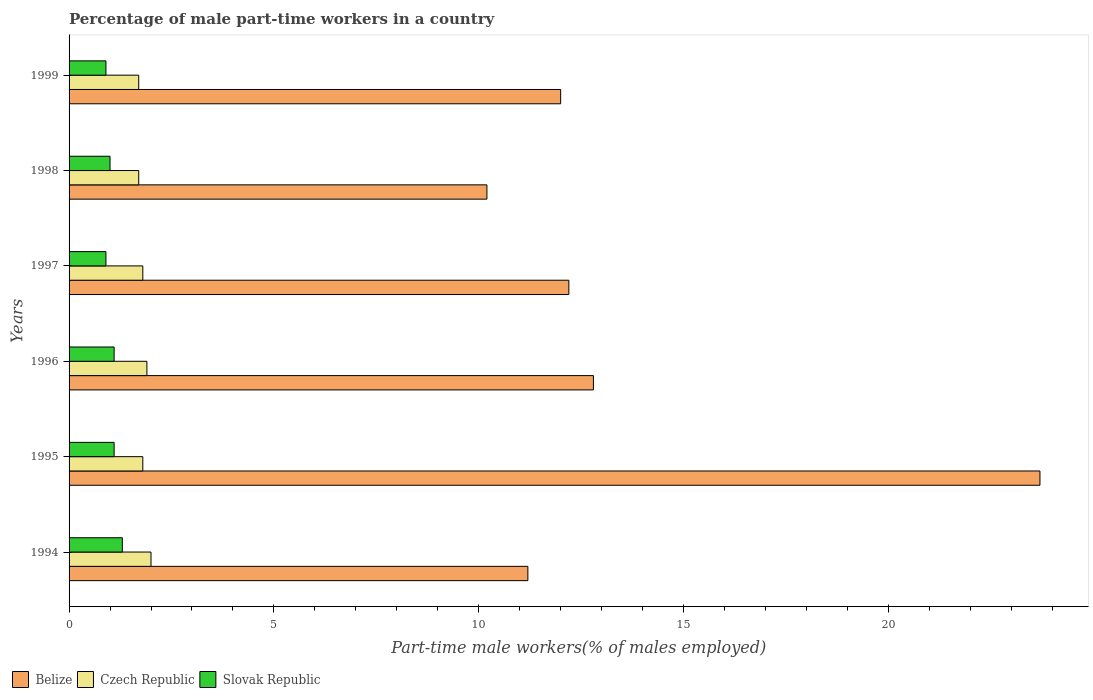How many bars are there on the 4th tick from the top?
Your answer should be very brief. 3. How many bars are there on the 1st tick from the bottom?
Offer a very short reply. 3. In how many cases, is the number of bars for a given year not equal to the number of legend labels?
Offer a very short reply. 0. What is the percentage of male part-time workers in Czech Republic in 1994?
Provide a short and direct response. 2. Across all years, what is the maximum percentage of male part-time workers in Slovak Republic?
Offer a very short reply. 1.3. Across all years, what is the minimum percentage of male part-time workers in Slovak Republic?
Offer a very short reply. 0.9. In which year was the percentage of male part-time workers in Belize minimum?
Provide a succinct answer. 1998. What is the total percentage of male part-time workers in Czech Republic in the graph?
Offer a very short reply. 10.9. What is the difference between the percentage of male part-time workers in Slovak Republic in 1998 and that in 1999?
Your answer should be very brief. 0.1. What is the difference between the percentage of male part-time workers in Belize in 1995 and the percentage of male part-time workers in Czech Republic in 1997?
Provide a short and direct response. 21.9. What is the average percentage of male part-time workers in Slovak Republic per year?
Provide a short and direct response. 1.05. In the year 1999, what is the difference between the percentage of male part-time workers in Belize and percentage of male part-time workers in Czech Republic?
Keep it short and to the point. 10.3. In how many years, is the percentage of male part-time workers in Belize greater than 5 %?
Provide a succinct answer. 6. Is the difference between the percentage of male part-time workers in Belize in 1994 and 1996 greater than the difference between the percentage of male part-time workers in Czech Republic in 1994 and 1996?
Your response must be concise. No. What is the difference between the highest and the second highest percentage of male part-time workers in Slovak Republic?
Offer a terse response. 0.2. What is the difference between the highest and the lowest percentage of male part-time workers in Belize?
Make the answer very short. 13.5. In how many years, is the percentage of male part-time workers in Slovak Republic greater than the average percentage of male part-time workers in Slovak Republic taken over all years?
Offer a very short reply. 3. What does the 3rd bar from the top in 1996 represents?
Offer a very short reply. Belize. What does the 1st bar from the bottom in 1997 represents?
Your answer should be compact. Belize. Is it the case that in every year, the sum of the percentage of male part-time workers in Belize and percentage of male part-time workers in Slovak Republic is greater than the percentage of male part-time workers in Czech Republic?
Make the answer very short. Yes. How many years are there in the graph?
Provide a short and direct response. 6. Are the values on the major ticks of X-axis written in scientific E-notation?
Give a very brief answer. No. Does the graph contain grids?
Offer a terse response. No. How many legend labels are there?
Your response must be concise. 3. How are the legend labels stacked?
Ensure brevity in your answer.  Horizontal. What is the title of the graph?
Your response must be concise. Percentage of male part-time workers in a country. Does "Cote d'Ivoire" appear as one of the legend labels in the graph?
Make the answer very short. No. What is the label or title of the X-axis?
Your answer should be compact. Part-time male workers(% of males employed). What is the Part-time male workers(% of males employed) in Belize in 1994?
Keep it short and to the point. 11.2. What is the Part-time male workers(% of males employed) in Slovak Republic in 1994?
Provide a succinct answer. 1.3. What is the Part-time male workers(% of males employed) in Belize in 1995?
Ensure brevity in your answer.  23.7. What is the Part-time male workers(% of males employed) of Czech Republic in 1995?
Provide a short and direct response. 1.8. What is the Part-time male workers(% of males employed) in Slovak Republic in 1995?
Your answer should be compact. 1.1. What is the Part-time male workers(% of males employed) in Belize in 1996?
Offer a terse response. 12.8. What is the Part-time male workers(% of males employed) of Czech Republic in 1996?
Give a very brief answer. 1.9. What is the Part-time male workers(% of males employed) of Slovak Republic in 1996?
Offer a very short reply. 1.1. What is the Part-time male workers(% of males employed) in Belize in 1997?
Offer a very short reply. 12.2. What is the Part-time male workers(% of males employed) of Czech Republic in 1997?
Your response must be concise. 1.8. What is the Part-time male workers(% of males employed) of Slovak Republic in 1997?
Your response must be concise. 0.9. What is the Part-time male workers(% of males employed) of Belize in 1998?
Keep it short and to the point. 10.2. What is the Part-time male workers(% of males employed) of Czech Republic in 1998?
Make the answer very short. 1.7. What is the Part-time male workers(% of males employed) of Czech Republic in 1999?
Offer a terse response. 1.7. What is the Part-time male workers(% of males employed) in Slovak Republic in 1999?
Provide a short and direct response. 0.9. Across all years, what is the maximum Part-time male workers(% of males employed) in Belize?
Your answer should be very brief. 23.7. Across all years, what is the maximum Part-time male workers(% of males employed) of Czech Republic?
Provide a succinct answer. 2. Across all years, what is the maximum Part-time male workers(% of males employed) of Slovak Republic?
Make the answer very short. 1.3. Across all years, what is the minimum Part-time male workers(% of males employed) in Belize?
Ensure brevity in your answer.  10.2. Across all years, what is the minimum Part-time male workers(% of males employed) of Czech Republic?
Your response must be concise. 1.7. Across all years, what is the minimum Part-time male workers(% of males employed) in Slovak Republic?
Offer a very short reply. 0.9. What is the total Part-time male workers(% of males employed) of Belize in the graph?
Ensure brevity in your answer.  82.1. What is the difference between the Part-time male workers(% of males employed) in Belize in 1994 and that in 1995?
Offer a very short reply. -12.5. What is the difference between the Part-time male workers(% of males employed) in Czech Republic in 1994 and that in 1995?
Make the answer very short. 0.2. What is the difference between the Part-time male workers(% of males employed) of Slovak Republic in 1994 and that in 1995?
Provide a succinct answer. 0.2. What is the difference between the Part-time male workers(% of males employed) in Slovak Republic in 1994 and that in 1996?
Make the answer very short. 0.2. What is the difference between the Part-time male workers(% of males employed) in Czech Republic in 1994 and that in 1997?
Provide a short and direct response. 0.2. What is the difference between the Part-time male workers(% of males employed) of Slovak Republic in 1994 and that in 1997?
Your response must be concise. 0.4. What is the difference between the Part-time male workers(% of males employed) of Belize in 1994 and that in 1998?
Your answer should be very brief. 1. What is the difference between the Part-time male workers(% of males employed) in Czech Republic in 1994 and that in 1999?
Your response must be concise. 0.3. What is the difference between the Part-time male workers(% of males employed) of Slovak Republic in 1994 and that in 1999?
Ensure brevity in your answer.  0.4. What is the difference between the Part-time male workers(% of males employed) of Czech Republic in 1995 and that in 1996?
Your response must be concise. -0.1. What is the difference between the Part-time male workers(% of males employed) in Czech Republic in 1995 and that in 1997?
Make the answer very short. 0. What is the difference between the Part-time male workers(% of males employed) of Slovak Republic in 1995 and that in 1998?
Your answer should be compact. 0.1. What is the difference between the Part-time male workers(% of males employed) in Belize in 1995 and that in 1999?
Provide a short and direct response. 11.7. What is the difference between the Part-time male workers(% of males employed) of Belize in 1996 and that in 1997?
Your answer should be very brief. 0.6. What is the difference between the Part-time male workers(% of males employed) in Belize in 1996 and that in 1998?
Offer a very short reply. 2.6. What is the difference between the Part-time male workers(% of males employed) of Slovak Republic in 1996 and that in 1999?
Your response must be concise. 0.2. What is the difference between the Part-time male workers(% of males employed) of Belize in 1997 and that in 1998?
Your answer should be very brief. 2. What is the difference between the Part-time male workers(% of males employed) of Slovak Republic in 1997 and that in 1998?
Your answer should be compact. -0.1. What is the difference between the Part-time male workers(% of males employed) of Slovak Republic in 1997 and that in 1999?
Provide a short and direct response. 0. What is the difference between the Part-time male workers(% of males employed) in Belize in 1998 and that in 1999?
Offer a very short reply. -1.8. What is the difference between the Part-time male workers(% of males employed) in Czech Republic in 1998 and that in 1999?
Offer a very short reply. 0. What is the difference between the Part-time male workers(% of males employed) of Belize in 1994 and the Part-time male workers(% of males employed) of Czech Republic in 1995?
Your response must be concise. 9.4. What is the difference between the Part-time male workers(% of males employed) of Belize in 1994 and the Part-time male workers(% of males employed) of Czech Republic in 1996?
Give a very brief answer. 9.3. What is the difference between the Part-time male workers(% of males employed) of Belize in 1994 and the Part-time male workers(% of males employed) of Czech Republic in 1997?
Your response must be concise. 9.4. What is the difference between the Part-time male workers(% of males employed) of Belize in 1994 and the Part-time male workers(% of males employed) of Czech Republic in 1998?
Offer a very short reply. 9.5. What is the difference between the Part-time male workers(% of males employed) in Belize in 1994 and the Part-time male workers(% of males employed) in Slovak Republic in 1998?
Your response must be concise. 10.2. What is the difference between the Part-time male workers(% of males employed) of Belize in 1994 and the Part-time male workers(% of males employed) of Czech Republic in 1999?
Your answer should be very brief. 9.5. What is the difference between the Part-time male workers(% of males employed) in Belize in 1994 and the Part-time male workers(% of males employed) in Slovak Republic in 1999?
Your response must be concise. 10.3. What is the difference between the Part-time male workers(% of males employed) of Belize in 1995 and the Part-time male workers(% of males employed) of Czech Republic in 1996?
Ensure brevity in your answer.  21.8. What is the difference between the Part-time male workers(% of males employed) in Belize in 1995 and the Part-time male workers(% of males employed) in Slovak Republic in 1996?
Give a very brief answer. 22.6. What is the difference between the Part-time male workers(% of males employed) in Czech Republic in 1995 and the Part-time male workers(% of males employed) in Slovak Republic in 1996?
Provide a short and direct response. 0.7. What is the difference between the Part-time male workers(% of males employed) of Belize in 1995 and the Part-time male workers(% of males employed) of Czech Republic in 1997?
Offer a very short reply. 21.9. What is the difference between the Part-time male workers(% of males employed) of Belize in 1995 and the Part-time male workers(% of males employed) of Slovak Republic in 1997?
Keep it short and to the point. 22.8. What is the difference between the Part-time male workers(% of males employed) of Czech Republic in 1995 and the Part-time male workers(% of males employed) of Slovak Republic in 1997?
Offer a very short reply. 0.9. What is the difference between the Part-time male workers(% of males employed) in Belize in 1995 and the Part-time male workers(% of males employed) in Czech Republic in 1998?
Give a very brief answer. 22. What is the difference between the Part-time male workers(% of males employed) in Belize in 1995 and the Part-time male workers(% of males employed) in Slovak Republic in 1998?
Your response must be concise. 22.7. What is the difference between the Part-time male workers(% of males employed) of Czech Republic in 1995 and the Part-time male workers(% of males employed) of Slovak Republic in 1998?
Ensure brevity in your answer.  0.8. What is the difference between the Part-time male workers(% of males employed) of Belize in 1995 and the Part-time male workers(% of males employed) of Slovak Republic in 1999?
Give a very brief answer. 22.8. What is the difference between the Part-time male workers(% of males employed) of Belize in 1996 and the Part-time male workers(% of males employed) of Czech Republic in 1997?
Give a very brief answer. 11. What is the difference between the Part-time male workers(% of males employed) in Belize in 1996 and the Part-time male workers(% of males employed) in Slovak Republic in 1998?
Offer a very short reply. 11.8. What is the difference between the Part-time male workers(% of males employed) of Belize in 1996 and the Part-time male workers(% of males employed) of Czech Republic in 1999?
Your answer should be very brief. 11.1. What is the difference between the Part-time male workers(% of males employed) in Czech Republic in 1996 and the Part-time male workers(% of males employed) in Slovak Republic in 1999?
Your answer should be compact. 1. What is the difference between the Part-time male workers(% of males employed) in Belize in 1997 and the Part-time male workers(% of males employed) in Czech Republic in 1998?
Keep it short and to the point. 10.5. What is the difference between the Part-time male workers(% of males employed) of Czech Republic in 1997 and the Part-time male workers(% of males employed) of Slovak Republic in 1998?
Your answer should be very brief. 0.8. What is the difference between the Part-time male workers(% of males employed) of Belize in 1997 and the Part-time male workers(% of males employed) of Czech Republic in 1999?
Ensure brevity in your answer.  10.5. What is the difference between the Part-time male workers(% of males employed) in Czech Republic in 1997 and the Part-time male workers(% of males employed) in Slovak Republic in 1999?
Your answer should be very brief. 0.9. What is the average Part-time male workers(% of males employed) of Belize per year?
Offer a terse response. 13.68. What is the average Part-time male workers(% of males employed) in Czech Republic per year?
Offer a terse response. 1.82. In the year 1994, what is the difference between the Part-time male workers(% of males employed) in Belize and Part-time male workers(% of males employed) in Slovak Republic?
Make the answer very short. 9.9. In the year 1994, what is the difference between the Part-time male workers(% of males employed) of Czech Republic and Part-time male workers(% of males employed) of Slovak Republic?
Offer a terse response. 0.7. In the year 1995, what is the difference between the Part-time male workers(% of males employed) in Belize and Part-time male workers(% of males employed) in Czech Republic?
Make the answer very short. 21.9. In the year 1995, what is the difference between the Part-time male workers(% of males employed) of Belize and Part-time male workers(% of males employed) of Slovak Republic?
Your answer should be compact. 22.6. In the year 1996, what is the difference between the Part-time male workers(% of males employed) in Belize and Part-time male workers(% of males employed) in Czech Republic?
Offer a terse response. 10.9. In the year 1997, what is the difference between the Part-time male workers(% of males employed) of Belize and Part-time male workers(% of males employed) of Czech Republic?
Your response must be concise. 10.4. In the year 1997, what is the difference between the Part-time male workers(% of males employed) in Belize and Part-time male workers(% of males employed) in Slovak Republic?
Your response must be concise. 11.3. In the year 1997, what is the difference between the Part-time male workers(% of males employed) in Czech Republic and Part-time male workers(% of males employed) in Slovak Republic?
Offer a very short reply. 0.9. In the year 1998, what is the difference between the Part-time male workers(% of males employed) in Belize and Part-time male workers(% of males employed) in Czech Republic?
Your answer should be compact. 8.5. In the year 1998, what is the difference between the Part-time male workers(% of males employed) in Belize and Part-time male workers(% of males employed) in Slovak Republic?
Make the answer very short. 9.2. In the year 1999, what is the difference between the Part-time male workers(% of males employed) in Czech Republic and Part-time male workers(% of males employed) in Slovak Republic?
Give a very brief answer. 0.8. What is the ratio of the Part-time male workers(% of males employed) in Belize in 1994 to that in 1995?
Offer a terse response. 0.47. What is the ratio of the Part-time male workers(% of males employed) in Czech Republic in 1994 to that in 1995?
Make the answer very short. 1.11. What is the ratio of the Part-time male workers(% of males employed) of Slovak Republic in 1994 to that in 1995?
Provide a short and direct response. 1.18. What is the ratio of the Part-time male workers(% of males employed) of Czech Republic in 1994 to that in 1996?
Your response must be concise. 1.05. What is the ratio of the Part-time male workers(% of males employed) of Slovak Republic in 1994 to that in 1996?
Your answer should be very brief. 1.18. What is the ratio of the Part-time male workers(% of males employed) of Belize in 1994 to that in 1997?
Provide a short and direct response. 0.92. What is the ratio of the Part-time male workers(% of males employed) of Slovak Republic in 1994 to that in 1997?
Your answer should be compact. 1.44. What is the ratio of the Part-time male workers(% of males employed) in Belize in 1994 to that in 1998?
Offer a very short reply. 1.1. What is the ratio of the Part-time male workers(% of males employed) in Czech Republic in 1994 to that in 1998?
Keep it short and to the point. 1.18. What is the ratio of the Part-time male workers(% of males employed) in Slovak Republic in 1994 to that in 1998?
Provide a short and direct response. 1.3. What is the ratio of the Part-time male workers(% of males employed) of Belize in 1994 to that in 1999?
Your response must be concise. 0.93. What is the ratio of the Part-time male workers(% of males employed) of Czech Republic in 1994 to that in 1999?
Provide a succinct answer. 1.18. What is the ratio of the Part-time male workers(% of males employed) in Slovak Republic in 1994 to that in 1999?
Your response must be concise. 1.44. What is the ratio of the Part-time male workers(% of males employed) in Belize in 1995 to that in 1996?
Give a very brief answer. 1.85. What is the ratio of the Part-time male workers(% of males employed) in Slovak Republic in 1995 to that in 1996?
Give a very brief answer. 1. What is the ratio of the Part-time male workers(% of males employed) of Belize in 1995 to that in 1997?
Ensure brevity in your answer.  1.94. What is the ratio of the Part-time male workers(% of males employed) in Slovak Republic in 1995 to that in 1997?
Make the answer very short. 1.22. What is the ratio of the Part-time male workers(% of males employed) in Belize in 1995 to that in 1998?
Provide a succinct answer. 2.32. What is the ratio of the Part-time male workers(% of males employed) in Czech Republic in 1995 to that in 1998?
Give a very brief answer. 1.06. What is the ratio of the Part-time male workers(% of males employed) of Slovak Republic in 1995 to that in 1998?
Make the answer very short. 1.1. What is the ratio of the Part-time male workers(% of males employed) in Belize in 1995 to that in 1999?
Ensure brevity in your answer.  1.98. What is the ratio of the Part-time male workers(% of males employed) of Czech Republic in 1995 to that in 1999?
Offer a very short reply. 1.06. What is the ratio of the Part-time male workers(% of males employed) in Slovak Republic in 1995 to that in 1999?
Give a very brief answer. 1.22. What is the ratio of the Part-time male workers(% of males employed) in Belize in 1996 to that in 1997?
Provide a succinct answer. 1.05. What is the ratio of the Part-time male workers(% of males employed) of Czech Republic in 1996 to that in 1997?
Make the answer very short. 1.06. What is the ratio of the Part-time male workers(% of males employed) in Slovak Republic in 1996 to that in 1997?
Offer a terse response. 1.22. What is the ratio of the Part-time male workers(% of males employed) in Belize in 1996 to that in 1998?
Provide a short and direct response. 1.25. What is the ratio of the Part-time male workers(% of males employed) of Czech Republic in 1996 to that in 1998?
Offer a terse response. 1.12. What is the ratio of the Part-time male workers(% of males employed) of Slovak Republic in 1996 to that in 1998?
Keep it short and to the point. 1.1. What is the ratio of the Part-time male workers(% of males employed) in Belize in 1996 to that in 1999?
Your response must be concise. 1.07. What is the ratio of the Part-time male workers(% of males employed) of Czech Republic in 1996 to that in 1999?
Ensure brevity in your answer.  1.12. What is the ratio of the Part-time male workers(% of males employed) of Slovak Republic in 1996 to that in 1999?
Make the answer very short. 1.22. What is the ratio of the Part-time male workers(% of males employed) in Belize in 1997 to that in 1998?
Give a very brief answer. 1.2. What is the ratio of the Part-time male workers(% of males employed) of Czech Republic in 1997 to that in 1998?
Provide a succinct answer. 1.06. What is the ratio of the Part-time male workers(% of males employed) of Slovak Republic in 1997 to that in 1998?
Offer a terse response. 0.9. What is the ratio of the Part-time male workers(% of males employed) in Belize in 1997 to that in 1999?
Your response must be concise. 1.02. What is the ratio of the Part-time male workers(% of males employed) of Czech Republic in 1997 to that in 1999?
Your response must be concise. 1.06. What is the ratio of the Part-time male workers(% of males employed) in Czech Republic in 1998 to that in 1999?
Offer a very short reply. 1. What is the difference between the highest and the second highest Part-time male workers(% of males employed) of Belize?
Your response must be concise. 10.9. What is the difference between the highest and the second highest Part-time male workers(% of males employed) of Slovak Republic?
Give a very brief answer. 0.2. What is the difference between the highest and the lowest Part-time male workers(% of males employed) of Belize?
Make the answer very short. 13.5. 